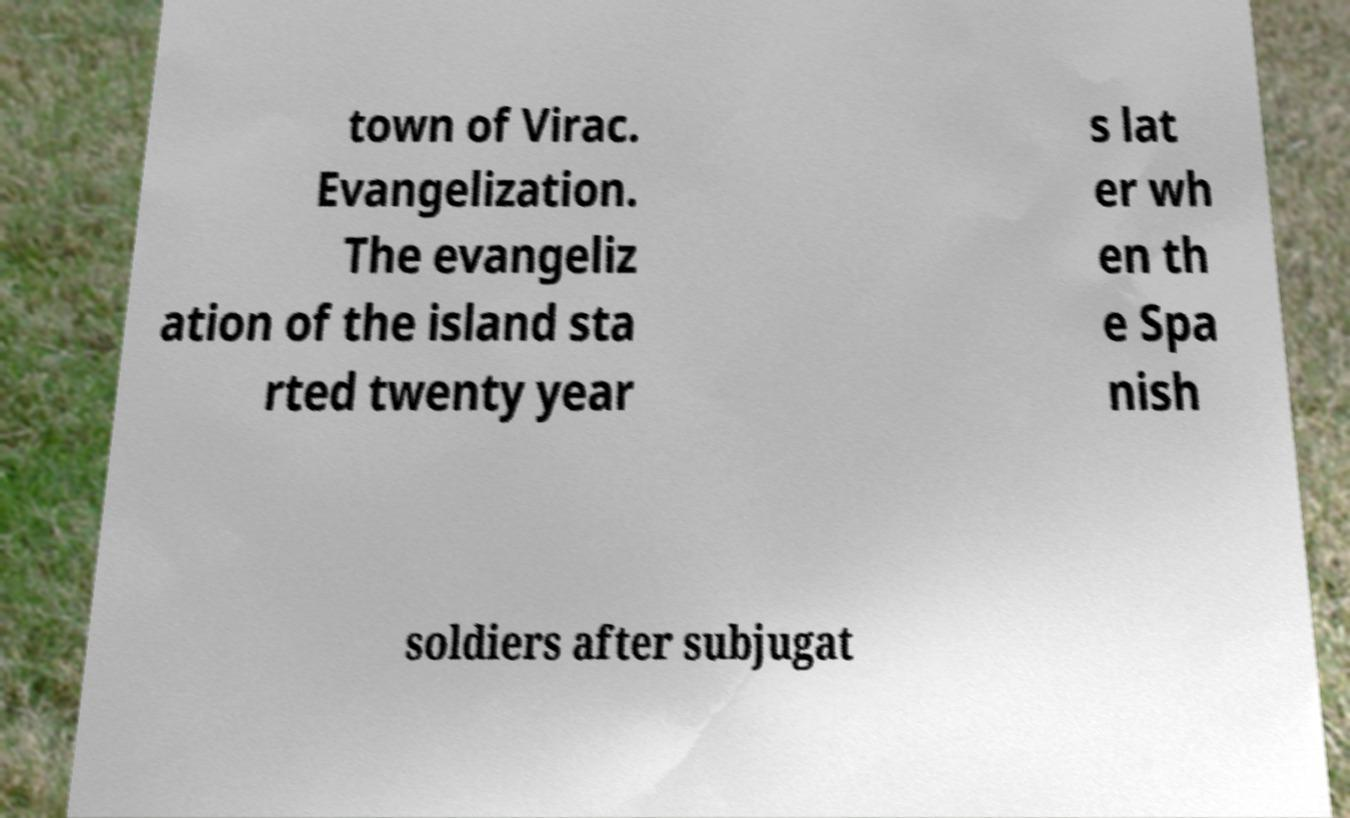For documentation purposes, I need the text within this image transcribed. Could you provide that? town of Virac. Evangelization. The evangeliz ation of the island sta rted twenty year s lat er wh en th e Spa nish soldiers after subjugat 